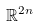Convert formula to latex. <formula><loc_0><loc_0><loc_500><loc_500>\mathbb { R } ^ { 2 n }</formula> 